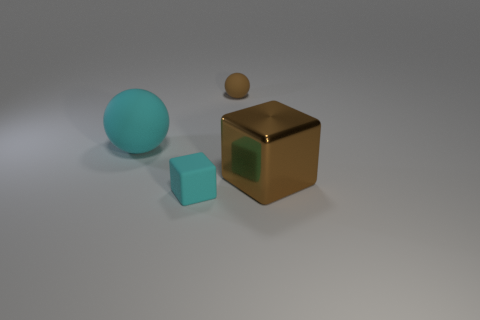Is there anything else that is the same material as the big cube?
Your response must be concise. No. There is another object that is the same size as the brown shiny object; what material is it?
Provide a short and direct response. Rubber. The matte thing that is in front of the tiny brown matte thing and behind the big shiny cube is what color?
Ensure brevity in your answer.  Cyan. What number of other things are there of the same color as the tiny matte ball?
Give a very brief answer. 1. The cyan object that is behind the tiny rubber thing that is in front of the cube that is right of the cyan rubber block is made of what material?
Give a very brief answer. Rubber. There is a large thing to the right of the cyan rubber thing that is on the left side of the small rubber block; what number of tiny matte things are in front of it?
Your response must be concise. 1. Do the large matte thing and the big brown thing have the same shape?
Give a very brief answer. No. Is the tiny object in front of the small rubber sphere made of the same material as the large thing behind the big block?
Your answer should be very brief. Yes. How many things are either balls that are right of the large rubber thing or matte objects that are right of the small rubber block?
Your response must be concise. 1. Are the large sphere and the block that is to the left of the large brown metal object made of the same material?
Provide a succinct answer. Yes. 